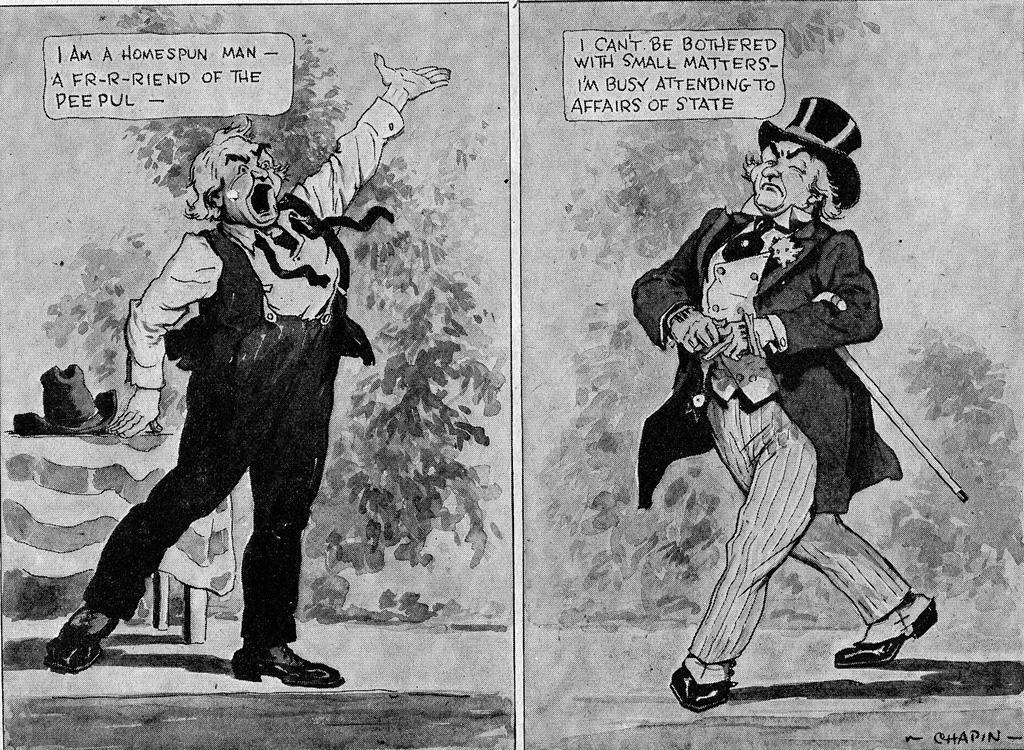Describe this image in one or two sentences. This is a collage image, in this image there are pictures and some text of a cartoon. 